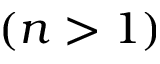<formula> <loc_0><loc_0><loc_500><loc_500>( n > 1 )</formula> 